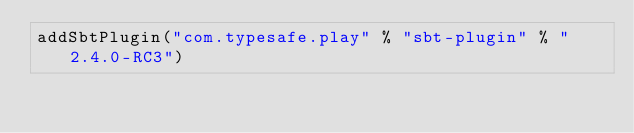<code> <loc_0><loc_0><loc_500><loc_500><_Scala_>addSbtPlugin("com.typesafe.play" % "sbt-plugin" % "2.4.0-RC3")
</code> 